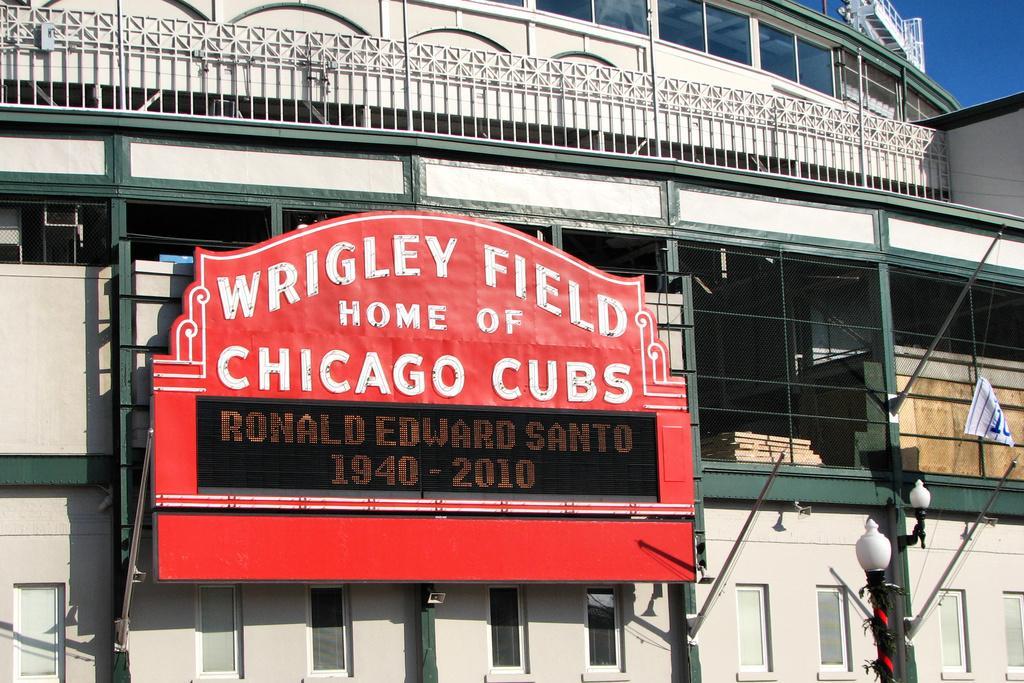Can you describe this image briefly? In the center of the image there is a board on the building. In the background we can see building and sky. At the bottom right corner there are lights. 